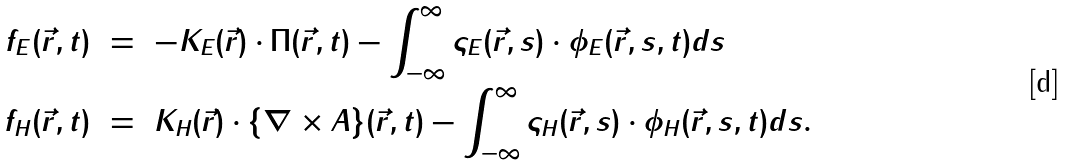<formula> <loc_0><loc_0><loc_500><loc_500>f _ { E } ( \vec { r } , t ) \ & = \ - K _ { E } ( \vec { r } ) \cdot \Pi ( \vec { r } , t ) - \int _ { - \infty } ^ { \infty } \varsigma _ { E } ( \vec { r } , s ) \cdot \phi _ { E } ( \vec { r } , s , t ) d s \\ f _ { H } ( \vec { r } , t ) \ & = \ K _ { H } ( \vec { r } ) \cdot \{ \nabla \times A \} ( \vec { r } , t ) - \int _ { - \infty } ^ { \infty } \varsigma _ { H } ( \vec { r } , s ) \cdot \phi _ { H } ( \vec { r } , s , t ) d s .</formula> 